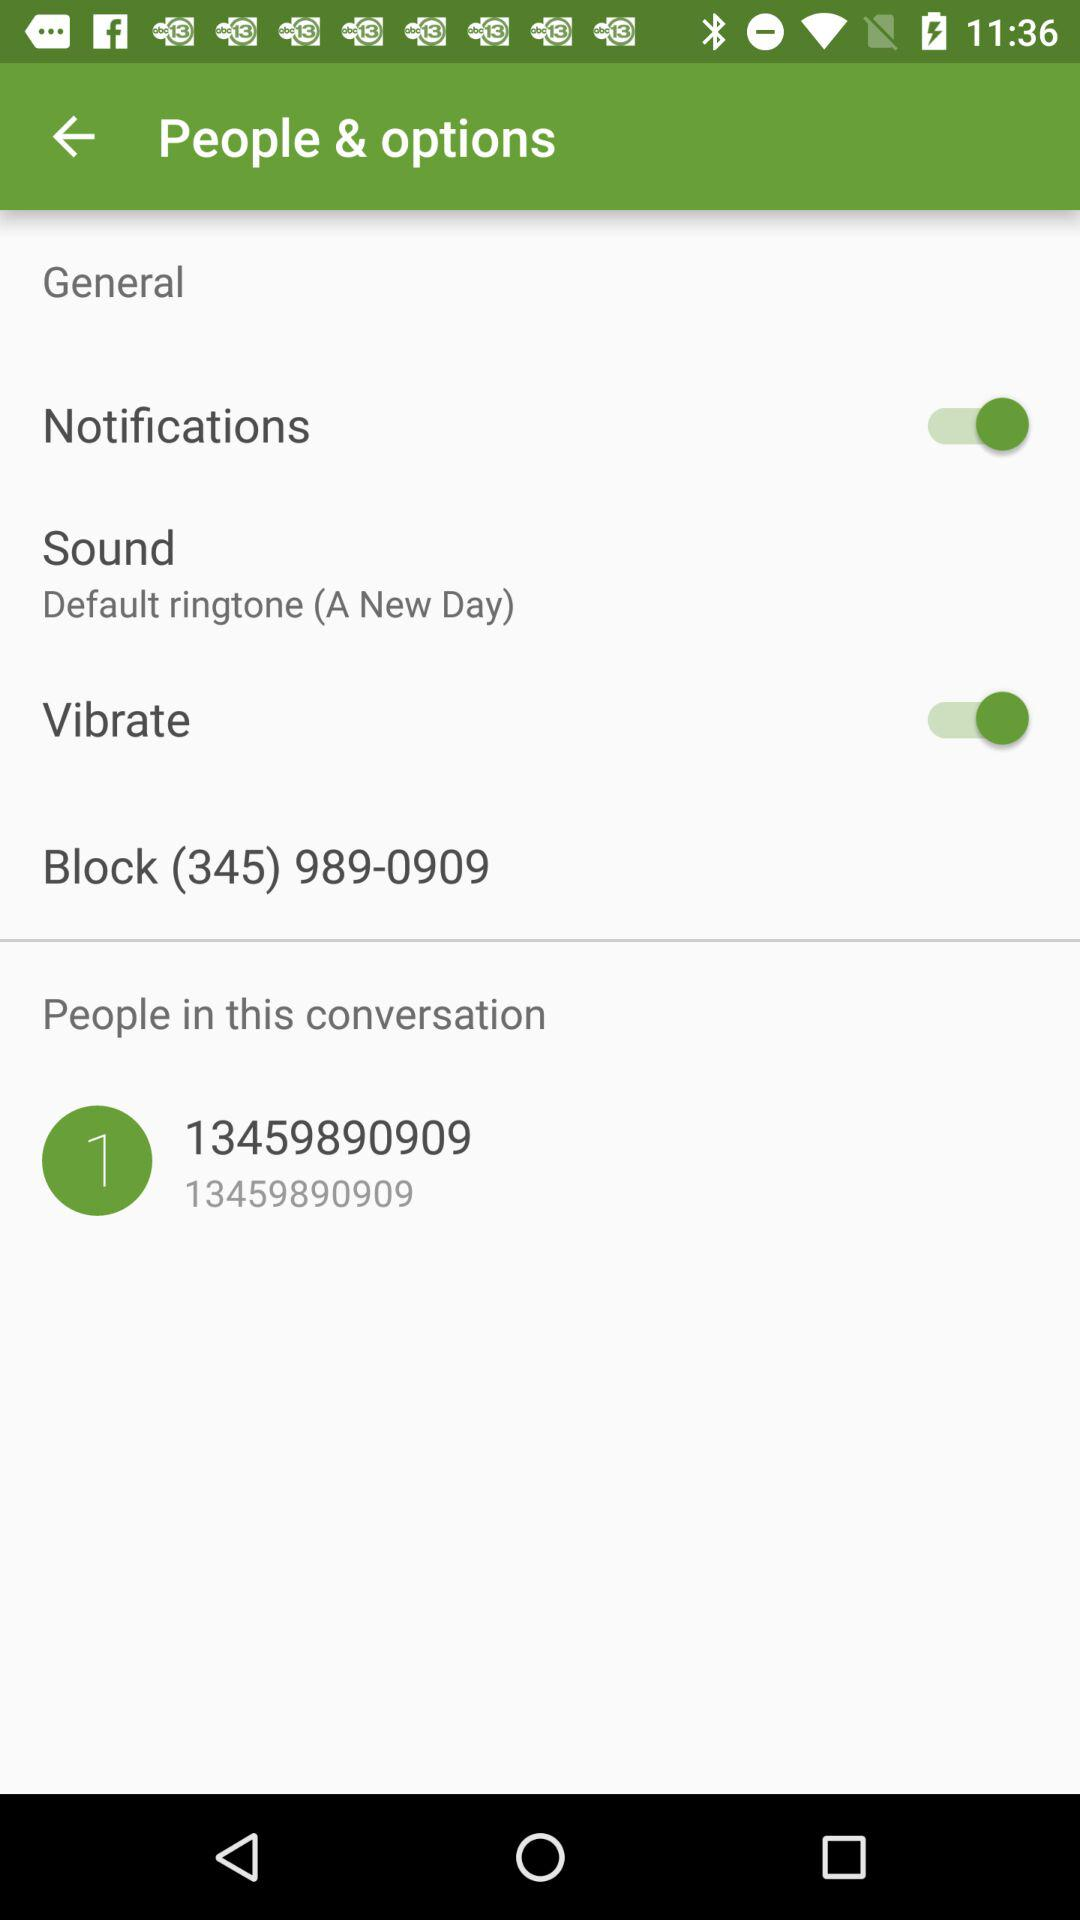What contact number is shown in "People in this conversion"? The shown contact number is 13459890909. 